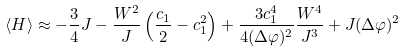<formula> <loc_0><loc_0><loc_500><loc_500>\langle H \rangle \approx - \frac { 3 } { 4 } J - \frac { W ^ { 2 } } { J } \left ( \frac { c _ { 1 } } { 2 } - c _ { 1 } ^ { 2 } \right ) + \frac { 3 c _ { 1 } ^ { 4 } } { 4 ( \Delta \varphi ) ^ { 2 } } \frac { W ^ { 4 } } { J ^ { 3 } } + J ( \Delta \varphi ) ^ { 2 }</formula> 